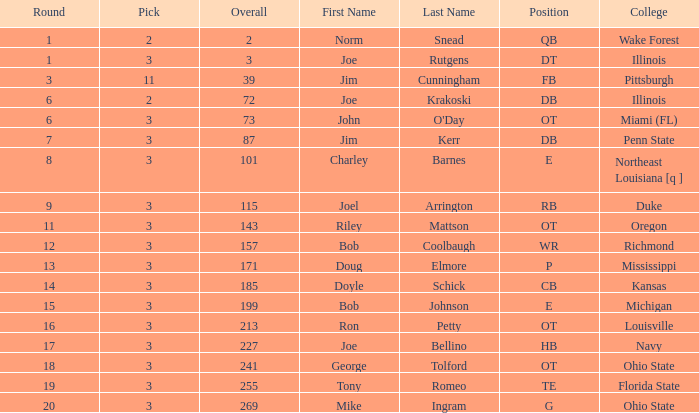How many overalls have charley barnes as the name, with a pick less than 3? None. 